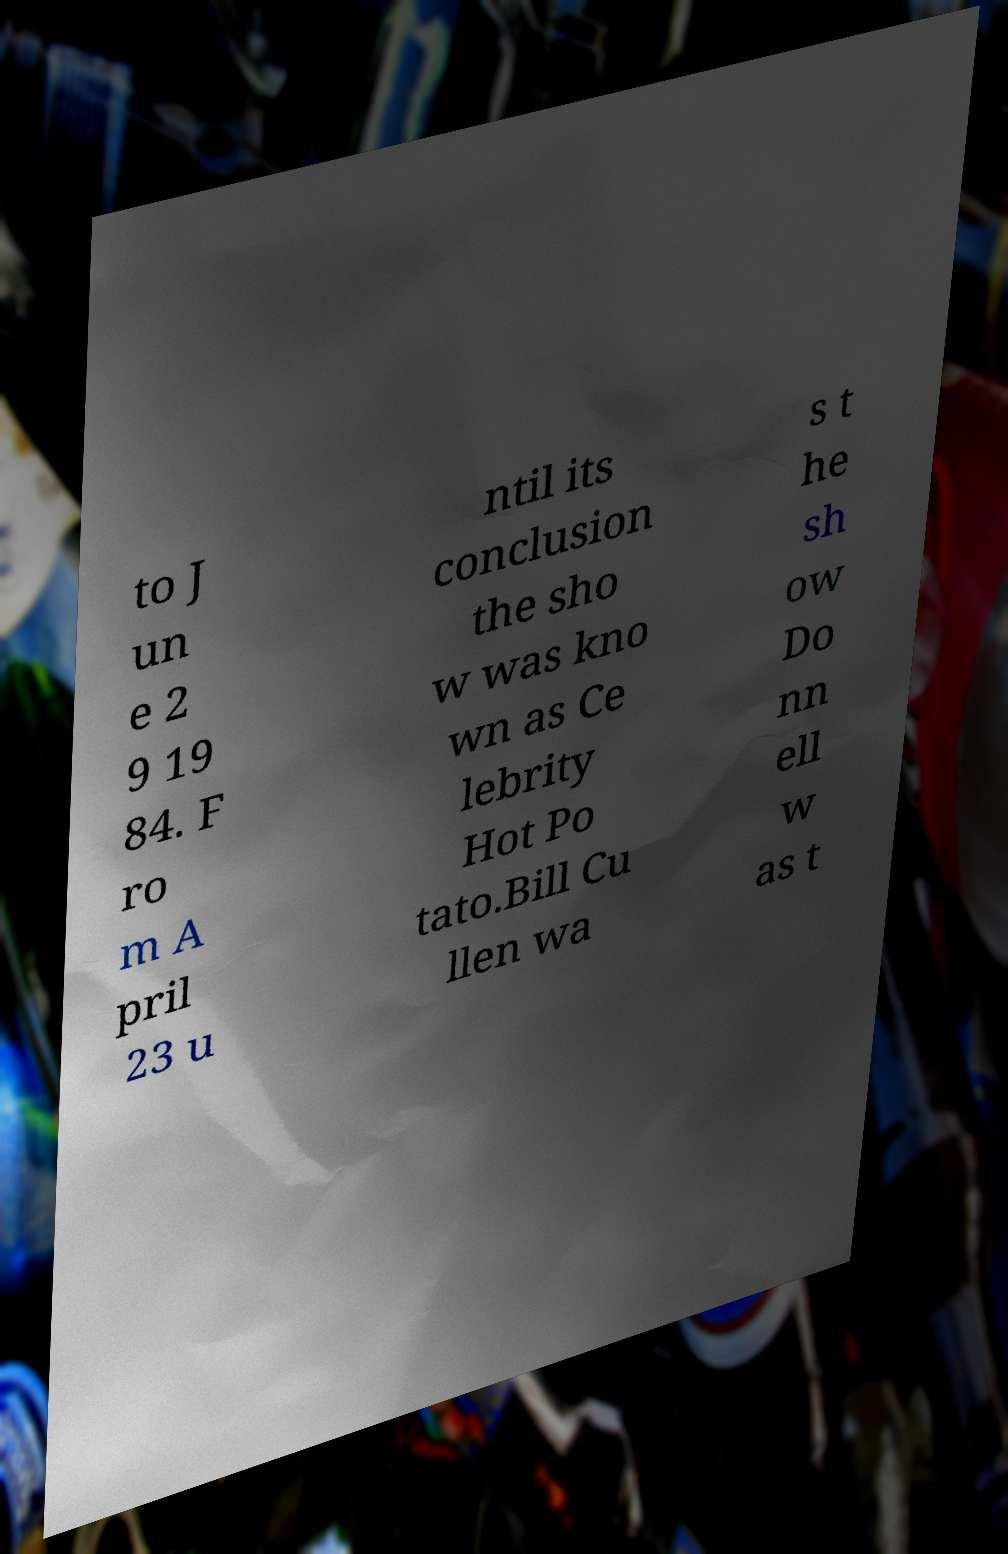Could you extract and type out the text from this image? to J un e 2 9 19 84. F ro m A pril 23 u ntil its conclusion the sho w was kno wn as Ce lebrity Hot Po tato.Bill Cu llen wa s t he sh ow Do nn ell w as t 